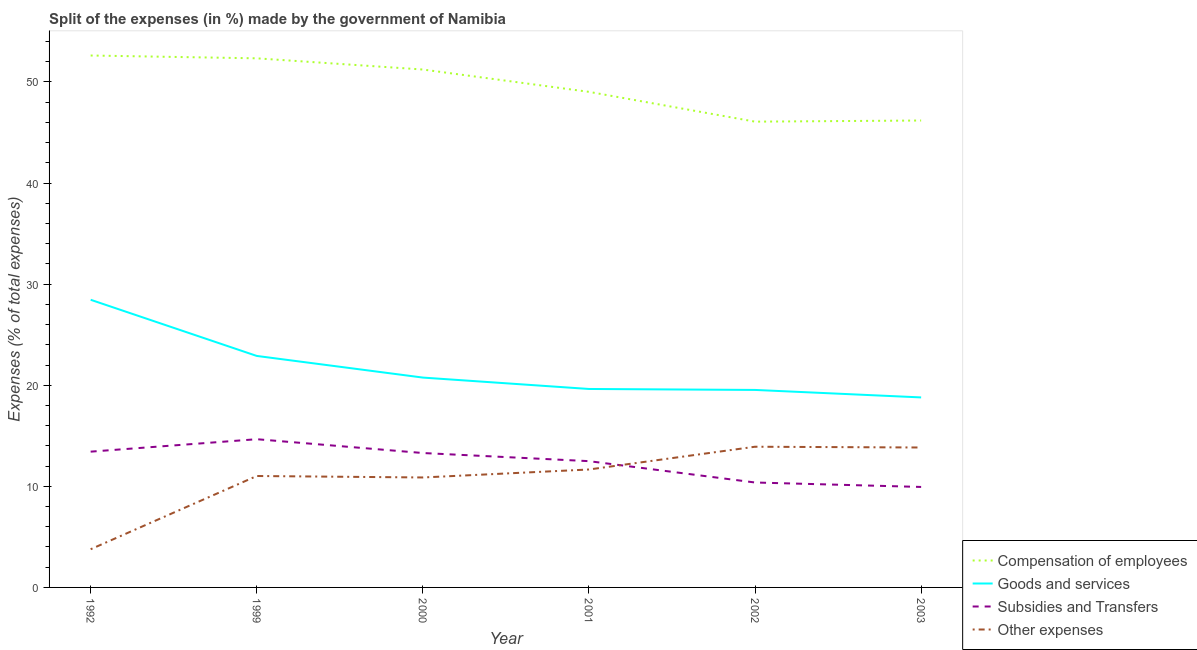Is the number of lines equal to the number of legend labels?
Your answer should be very brief. Yes. What is the percentage of amount spent on compensation of employees in 1992?
Your answer should be compact. 52.62. Across all years, what is the maximum percentage of amount spent on goods and services?
Offer a very short reply. 28.46. Across all years, what is the minimum percentage of amount spent on goods and services?
Keep it short and to the point. 18.8. What is the total percentage of amount spent on other expenses in the graph?
Your answer should be very brief. 65.1. What is the difference between the percentage of amount spent on compensation of employees in 2001 and that in 2002?
Your response must be concise. 2.95. What is the difference between the percentage of amount spent on compensation of employees in 2002 and the percentage of amount spent on goods and services in 2003?
Offer a very short reply. 27.28. What is the average percentage of amount spent on subsidies per year?
Offer a very short reply. 12.37. In the year 1992, what is the difference between the percentage of amount spent on other expenses and percentage of amount spent on goods and services?
Ensure brevity in your answer.  -24.68. In how many years, is the percentage of amount spent on goods and services greater than 38 %?
Make the answer very short. 0. What is the ratio of the percentage of amount spent on compensation of employees in 1992 to that in 2000?
Make the answer very short. 1.03. Is the difference between the percentage of amount spent on subsidies in 1999 and 2001 greater than the difference between the percentage of amount spent on other expenses in 1999 and 2001?
Your answer should be compact. Yes. What is the difference between the highest and the second highest percentage of amount spent on other expenses?
Provide a succinct answer. 0.08. What is the difference between the highest and the lowest percentage of amount spent on compensation of employees?
Give a very brief answer. 6.54. In how many years, is the percentage of amount spent on subsidies greater than the average percentage of amount spent on subsidies taken over all years?
Keep it short and to the point. 4. Does the percentage of amount spent on goods and services monotonically increase over the years?
Your answer should be compact. No. Is the percentage of amount spent on other expenses strictly greater than the percentage of amount spent on compensation of employees over the years?
Provide a succinct answer. No. What is the difference between two consecutive major ticks on the Y-axis?
Offer a terse response. 10. Does the graph contain grids?
Give a very brief answer. No. How many legend labels are there?
Your answer should be compact. 4. How are the legend labels stacked?
Provide a succinct answer. Vertical. What is the title of the graph?
Provide a short and direct response. Split of the expenses (in %) made by the government of Namibia. Does "Iceland" appear as one of the legend labels in the graph?
Provide a short and direct response. No. What is the label or title of the Y-axis?
Make the answer very short. Expenses (% of total expenses). What is the Expenses (% of total expenses) of Compensation of employees in 1992?
Offer a very short reply. 52.62. What is the Expenses (% of total expenses) of Goods and services in 1992?
Your answer should be compact. 28.46. What is the Expenses (% of total expenses) of Subsidies and Transfers in 1992?
Your response must be concise. 13.43. What is the Expenses (% of total expenses) of Other expenses in 1992?
Your answer should be very brief. 3.78. What is the Expenses (% of total expenses) of Compensation of employees in 1999?
Your answer should be compact. 52.34. What is the Expenses (% of total expenses) of Goods and services in 1999?
Offer a terse response. 22.9. What is the Expenses (% of total expenses) in Subsidies and Transfers in 1999?
Make the answer very short. 14.66. What is the Expenses (% of total expenses) in Other expenses in 1999?
Make the answer very short. 11.02. What is the Expenses (% of total expenses) in Compensation of employees in 2000?
Ensure brevity in your answer.  51.23. What is the Expenses (% of total expenses) of Goods and services in 2000?
Your response must be concise. 20.76. What is the Expenses (% of total expenses) in Subsidies and Transfers in 2000?
Keep it short and to the point. 13.3. What is the Expenses (% of total expenses) of Other expenses in 2000?
Your response must be concise. 10.88. What is the Expenses (% of total expenses) in Compensation of employees in 2001?
Make the answer very short. 49.02. What is the Expenses (% of total expenses) in Goods and services in 2001?
Provide a short and direct response. 19.63. What is the Expenses (% of total expenses) of Subsidies and Transfers in 2001?
Provide a short and direct response. 12.49. What is the Expenses (% of total expenses) of Other expenses in 2001?
Offer a terse response. 11.67. What is the Expenses (% of total expenses) of Compensation of employees in 2002?
Ensure brevity in your answer.  46.08. What is the Expenses (% of total expenses) of Goods and services in 2002?
Offer a very short reply. 19.54. What is the Expenses (% of total expenses) of Subsidies and Transfers in 2002?
Keep it short and to the point. 10.38. What is the Expenses (% of total expenses) of Other expenses in 2002?
Your answer should be very brief. 13.92. What is the Expenses (% of total expenses) of Compensation of employees in 2003?
Your response must be concise. 46.19. What is the Expenses (% of total expenses) of Goods and services in 2003?
Offer a very short reply. 18.8. What is the Expenses (% of total expenses) of Subsidies and Transfers in 2003?
Your answer should be compact. 9.94. What is the Expenses (% of total expenses) in Other expenses in 2003?
Offer a very short reply. 13.84. Across all years, what is the maximum Expenses (% of total expenses) in Compensation of employees?
Give a very brief answer. 52.62. Across all years, what is the maximum Expenses (% of total expenses) in Goods and services?
Give a very brief answer. 28.46. Across all years, what is the maximum Expenses (% of total expenses) of Subsidies and Transfers?
Your answer should be compact. 14.66. Across all years, what is the maximum Expenses (% of total expenses) in Other expenses?
Offer a terse response. 13.92. Across all years, what is the minimum Expenses (% of total expenses) in Compensation of employees?
Ensure brevity in your answer.  46.08. Across all years, what is the minimum Expenses (% of total expenses) of Goods and services?
Keep it short and to the point. 18.8. Across all years, what is the minimum Expenses (% of total expenses) of Subsidies and Transfers?
Provide a short and direct response. 9.94. Across all years, what is the minimum Expenses (% of total expenses) of Other expenses?
Make the answer very short. 3.78. What is the total Expenses (% of total expenses) in Compensation of employees in the graph?
Offer a very short reply. 297.48. What is the total Expenses (% of total expenses) in Goods and services in the graph?
Your answer should be very brief. 130.08. What is the total Expenses (% of total expenses) in Subsidies and Transfers in the graph?
Offer a terse response. 74.2. What is the total Expenses (% of total expenses) in Other expenses in the graph?
Provide a succinct answer. 65.1. What is the difference between the Expenses (% of total expenses) in Compensation of employees in 1992 and that in 1999?
Give a very brief answer. 0.28. What is the difference between the Expenses (% of total expenses) of Goods and services in 1992 and that in 1999?
Your answer should be very brief. 5.56. What is the difference between the Expenses (% of total expenses) in Subsidies and Transfers in 1992 and that in 1999?
Make the answer very short. -1.23. What is the difference between the Expenses (% of total expenses) of Other expenses in 1992 and that in 1999?
Your answer should be compact. -7.24. What is the difference between the Expenses (% of total expenses) of Compensation of employees in 1992 and that in 2000?
Your answer should be compact. 1.39. What is the difference between the Expenses (% of total expenses) in Goods and services in 1992 and that in 2000?
Offer a very short reply. 7.7. What is the difference between the Expenses (% of total expenses) of Subsidies and Transfers in 1992 and that in 2000?
Offer a very short reply. 0.14. What is the difference between the Expenses (% of total expenses) of Other expenses in 1992 and that in 2000?
Your answer should be compact. -7.1. What is the difference between the Expenses (% of total expenses) of Compensation of employees in 1992 and that in 2001?
Your response must be concise. 3.59. What is the difference between the Expenses (% of total expenses) of Goods and services in 1992 and that in 2001?
Your answer should be very brief. 8.82. What is the difference between the Expenses (% of total expenses) in Subsidies and Transfers in 1992 and that in 2001?
Offer a terse response. 0.94. What is the difference between the Expenses (% of total expenses) in Other expenses in 1992 and that in 2001?
Provide a short and direct response. -7.89. What is the difference between the Expenses (% of total expenses) in Compensation of employees in 1992 and that in 2002?
Keep it short and to the point. 6.54. What is the difference between the Expenses (% of total expenses) in Goods and services in 1992 and that in 2002?
Offer a terse response. 8.92. What is the difference between the Expenses (% of total expenses) of Subsidies and Transfers in 1992 and that in 2002?
Offer a very short reply. 3.05. What is the difference between the Expenses (% of total expenses) of Other expenses in 1992 and that in 2002?
Your answer should be very brief. -10.14. What is the difference between the Expenses (% of total expenses) in Compensation of employees in 1992 and that in 2003?
Your response must be concise. 6.43. What is the difference between the Expenses (% of total expenses) of Goods and services in 1992 and that in 2003?
Offer a very short reply. 9.66. What is the difference between the Expenses (% of total expenses) in Subsidies and Transfers in 1992 and that in 2003?
Your answer should be very brief. 3.49. What is the difference between the Expenses (% of total expenses) in Other expenses in 1992 and that in 2003?
Your answer should be very brief. -10.06. What is the difference between the Expenses (% of total expenses) of Compensation of employees in 1999 and that in 2000?
Ensure brevity in your answer.  1.11. What is the difference between the Expenses (% of total expenses) of Goods and services in 1999 and that in 2000?
Your answer should be very brief. 2.14. What is the difference between the Expenses (% of total expenses) of Subsidies and Transfers in 1999 and that in 2000?
Ensure brevity in your answer.  1.37. What is the difference between the Expenses (% of total expenses) of Other expenses in 1999 and that in 2000?
Your answer should be compact. 0.15. What is the difference between the Expenses (% of total expenses) in Compensation of employees in 1999 and that in 2001?
Provide a succinct answer. 3.32. What is the difference between the Expenses (% of total expenses) of Goods and services in 1999 and that in 2001?
Offer a terse response. 3.27. What is the difference between the Expenses (% of total expenses) of Subsidies and Transfers in 1999 and that in 2001?
Ensure brevity in your answer.  2.17. What is the difference between the Expenses (% of total expenses) in Other expenses in 1999 and that in 2001?
Keep it short and to the point. -0.64. What is the difference between the Expenses (% of total expenses) of Compensation of employees in 1999 and that in 2002?
Your answer should be very brief. 6.26. What is the difference between the Expenses (% of total expenses) in Goods and services in 1999 and that in 2002?
Offer a very short reply. 3.36. What is the difference between the Expenses (% of total expenses) in Subsidies and Transfers in 1999 and that in 2002?
Offer a terse response. 4.28. What is the difference between the Expenses (% of total expenses) in Other expenses in 1999 and that in 2002?
Your answer should be compact. -2.9. What is the difference between the Expenses (% of total expenses) in Compensation of employees in 1999 and that in 2003?
Ensure brevity in your answer.  6.15. What is the difference between the Expenses (% of total expenses) in Goods and services in 1999 and that in 2003?
Your answer should be compact. 4.11. What is the difference between the Expenses (% of total expenses) of Subsidies and Transfers in 1999 and that in 2003?
Your response must be concise. 4.72. What is the difference between the Expenses (% of total expenses) of Other expenses in 1999 and that in 2003?
Give a very brief answer. -2.82. What is the difference between the Expenses (% of total expenses) of Compensation of employees in 2000 and that in 2001?
Ensure brevity in your answer.  2.21. What is the difference between the Expenses (% of total expenses) of Goods and services in 2000 and that in 2001?
Offer a very short reply. 1.13. What is the difference between the Expenses (% of total expenses) of Subsidies and Transfers in 2000 and that in 2001?
Ensure brevity in your answer.  0.8. What is the difference between the Expenses (% of total expenses) in Other expenses in 2000 and that in 2001?
Offer a terse response. -0.79. What is the difference between the Expenses (% of total expenses) of Compensation of employees in 2000 and that in 2002?
Offer a very short reply. 5.16. What is the difference between the Expenses (% of total expenses) of Goods and services in 2000 and that in 2002?
Your answer should be very brief. 1.22. What is the difference between the Expenses (% of total expenses) in Subsidies and Transfers in 2000 and that in 2002?
Offer a terse response. 2.92. What is the difference between the Expenses (% of total expenses) of Other expenses in 2000 and that in 2002?
Ensure brevity in your answer.  -3.04. What is the difference between the Expenses (% of total expenses) in Compensation of employees in 2000 and that in 2003?
Give a very brief answer. 5.04. What is the difference between the Expenses (% of total expenses) in Goods and services in 2000 and that in 2003?
Provide a succinct answer. 1.96. What is the difference between the Expenses (% of total expenses) in Subsidies and Transfers in 2000 and that in 2003?
Your answer should be compact. 3.36. What is the difference between the Expenses (% of total expenses) in Other expenses in 2000 and that in 2003?
Make the answer very short. -2.96. What is the difference between the Expenses (% of total expenses) of Compensation of employees in 2001 and that in 2002?
Your response must be concise. 2.95. What is the difference between the Expenses (% of total expenses) in Goods and services in 2001 and that in 2002?
Give a very brief answer. 0.1. What is the difference between the Expenses (% of total expenses) of Subsidies and Transfers in 2001 and that in 2002?
Offer a terse response. 2.11. What is the difference between the Expenses (% of total expenses) of Other expenses in 2001 and that in 2002?
Keep it short and to the point. -2.25. What is the difference between the Expenses (% of total expenses) in Compensation of employees in 2001 and that in 2003?
Your answer should be very brief. 2.84. What is the difference between the Expenses (% of total expenses) of Goods and services in 2001 and that in 2003?
Provide a succinct answer. 0.84. What is the difference between the Expenses (% of total expenses) in Subsidies and Transfers in 2001 and that in 2003?
Give a very brief answer. 2.55. What is the difference between the Expenses (% of total expenses) in Other expenses in 2001 and that in 2003?
Give a very brief answer. -2.17. What is the difference between the Expenses (% of total expenses) in Compensation of employees in 2002 and that in 2003?
Provide a succinct answer. -0.11. What is the difference between the Expenses (% of total expenses) in Goods and services in 2002 and that in 2003?
Make the answer very short. 0.74. What is the difference between the Expenses (% of total expenses) of Subsidies and Transfers in 2002 and that in 2003?
Provide a succinct answer. 0.44. What is the difference between the Expenses (% of total expenses) of Other expenses in 2002 and that in 2003?
Provide a short and direct response. 0.08. What is the difference between the Expenses (% of total expenses) in Compensation of employees in 1992 and the Expenses (% of total expenses) in Goods and services in 1999?
Keep it short and to the point. 29.72. What is the difference between the Expenses (% of total expenses) in Compensation of employees in 1992 and the Expenses (% of total expenses) in Subsidies and Transfers in 1999?
Make the answer very short. 37.96. What is the difference between the Expenses (% of total expenses) in Compensation of employees in 1992 and the Expenses (% of total expenses) in Other expenses in 1999?
Provide a short and direct response. 41.6. What is the difference between the Expenses (% of total expenses) of Goods and services in 1992 and the Expenses (% of total expenses) of Subsidies and Transfers in 1999?
Give a very brief answer. 13.79. What is the difference between the Expenses (% of total expenses) of Goods and services in 1992 and the Expenses (% of total expenses) of Other expenses in 1999?
Your answer should be compact. 17.43. What is the difference between the Expenses (% of total expenses) in Subsidies and Transfers in 1992 and the Expenses (% of total expenses) in Other expenses in 1999?
Your answer should be very brief. 2.41. What is the difference between the Expenses (% of total expenses) in Compensation of employees in 1992 and the Expenses (% of total expenses) in Goods and services in 2000?
Give a very brief answer. 31.86. What is the difference between the Expenses (% of total expenses) of Compensation of employees in 1992 and the Expenses (% of total expenses) of Subsidies and Transfers in 2000?
Provide a succinct answer. 39.32. What is the difference between the Expenses (% of total expenses) in Compensation of employees in 1992 and the Expenses (% of total expenses) in Other expenses in 2000?
Offer a very short reply. 41.74. What is the difference between the Expenses (% of total expenses) in Goods and services in 1992 and the Expenses (% of total expenses) in Subsidies and Transfers in 2000?
Make the answer very short. 15.16. What is the difference between the Expenses (% of total expenses) of Goods and services in 1992 and the Expenses (% of total expenses) of Other expenses in 2000?
Give a very brief answer. 17.58. What is the difference between the Expenses (% of total expenses) in Subsidies and Transfers in 1992 and the Expenses (% of total expenses) in Other expenses in 2000?
Provide a succinct answer. 2.55. What is the difference between the Expenses (% of total expenses) in Compensation of employees in 1992 and the Expenses (% of total expenses) in Goods and services in 2001?
Offer a terse response. 32.99. What is the difference between the Expenses (% of total expenses) of Compensation of employees in 1992 and the Expenses (% of total expenses) of Subsidies and Transfers in 2001?
Your answer should be compact. 40.13. What is the difference between the Expenses (% of total expenses) in Compensation of employees in 1992 and the Expenses (% of total expenses) in Other expenses in 2001?
Offer a terse response. 40.95. What is the difference between the Expenses (% of total expenses) of Goods and services in 1992 and the Expenses (% of total expenses) of Subsidies and Transfers in 2001?
Provide a short and direct response. 15.96. What is the difference between the Expenses (% of total expenses) of Goods and services in 1992 and the Expenses (% of total expenses) of Other expenses in 2001?
Your answer should be very brief. 16.79. What is the difference between the Expenses (% of total expenses) in Subsidies and Transfers in 1992 and the Expenses (% of total expenses) in Other expenses in 2001?
Provide a succinct answer. 1.76. What is the difference between the Expenses (% of total expenses) of Compensation of employees in 1992 and the Expenses (% of total expenses) of Goods and services in 2002?
Keep it short and to the point. 33.08. What is the difference between the Expenses (% of total expenses) of Compensation of employees in 1992 and the Expenses (% of total expenses) of Subsidies and Transfers in 2002?
Give a very brief answer. 42.24. What is the difference between the Expenses (% of total expenses) of Compensation of employees in 1992 and the Expenses (% of total expenses) of Other expenses in 2002?
Give a very brief answer. 38.7. What is the difference between the Expenses (% of total expenses) in Goods and services in 1992 and the Expenses (% of total expenses) in Subsidies and Transfers in 2002?
Provide a succinct answer. 18.08. What is the difference between the Expenses (% of total expenses) in Goods and services in 1992 and the Expenses (% of total expenses) in Other expenses in 2002?
Offer a very short reply. 14.54. What is the difference between the Expenses (% of total expenses) of Subsidies and Transfers in 1992 and the Expenses (% of total expenses) of Other expenses in 2002?
Give a very brief answer. -0.49. What is the difference between the Expenses (% of total expenses) in Compensation of employees in 1992 and the Expenses (% of total expenses) in Goods and services in 2003?
Keep it short and to the point. 33.82. What is the difference between the Expenses (% of total expenses) in Compensation of employees in 1992 and the Expenses (% of total expenses) in Subsidies and Transfers in 2003?
Offer a very short reply. 42.68. What is the difference between the Expenses (% of total expenses) of Compensation of employees in 1992 and the Expenses (% of total expenses) of Other expenses in 2003?
Offer a very short reply. 38.78. What is the difference between the Expenses (% of total expenses) of Goods and services in 1992 and the Expenses (% of total expenses) of Subsidies and Transfers in 2003?
Your answer should be compact. 18.52. What is the difference between the Expenses (% of total expenses) in Goods and services in 1992 and the Expenses (% of total expenses) in Other expenses in 2003?
Provide a succinct answer. 14.61. What is the difference between the Expenses (% of total expenses) in Subsidies and Transfers in 1992 and the Expenses (% of total expenses) in Other expenses in 2003?
Give a very brief answer. -0.41. What is the difference between the Expenses (% of total expenses) of Compensation of employees in 1999 and the Expenses (% of total expenses) of Goods and services in 2000?
Make the answer very short. 31.58. What is the difference between the Expenses (% of total expenses) in Compensation of employees in 1999 and the Expenses (% of total expenses) in Subsidies and Transfers in 2000?
Ensure brevity in your answer.  39.04. What is the difference between the Expenses (% of total expenses) of Compensation of employees in 1999 and the Expenses (% of total expenses) of Other expenses in 2000?
Offer a very short reply. 41.46. What is the difference between the Expenses (% of total expenses) of Goods and services in 1999 and the Expenses (% of total expenses) of Subsidies and Transfers in 2000?
Provide a short and direct response. 9.6. What is the difference between the Expenses (% of total expenses) of Goods and services in 1999 and the Expenses (% of total expenses) of Other expenses in 2000?
Your response must be concise. 12.02. What is the difference between the Expenses (% of total expenses) of Subsidies and Transfers in 1999 and the Expenses (% of total expenses) of Other expenses in 2000?
Make the answer very short. 3.79. What is the difference between the Expenses (% of total expenses) in Compensation of employees in 1999 and the Expenses (% of total expenses) in Goods and services in 2001?
Give a very brief answer. 32.71. What is the difference between the Expenses (% of total expenses) of Compensation of employees in 1999 and the Expenses (% of total expenses) of Subsidies and Transfers in 2001?
Give a very brief answer. 39.85. What is the difference between the Expenses (% of total expenses) of Compensation of employees in 1999 and the Expenses (% of total expenses) of Other expenses in 2001?
Your response must be concise. 40.67. What is the difference between the Expenses (% of total expenses) of Goods and services in 1999 and the Expenses (% of total expenses) of Subsidies and Transfers in 2001?
Provide a succinct answer. 10.41. What is the difference between the Expenses (% of total expenses) in Goods and services in 1999 and the Expenses (% of total expenses) in Other expenses in 2001?
Offer a terse response. 11.23. What is the difference between the Expenses (% of total expenses) in Subsidies and Transfers in 1999 and the Expenses (% of total expenses) in Other expenses in 2001?
Your answer should be compact. 3. What is the difference between the Expenses (% of total expenses) of Compensation of employees in 1999 and the Expenses (% of total expenses) of Goods and services in 2002?
Give a very brief answer. 32.8. What is the difference between the Expenses (% of total expenses) in Compensation of employees in 1999 and the Expenses (% of total expenses) in Subsidies and Transfers in 2002?
Your answer should be very brief. 41.96. What is the difference between the Expenses (% of total expenses) in Compensation of employees in 1999 and the Expenses (% of total expenses) in Other expenses in 2002?
Provide a succinct answer. 38.42. What is the difference between the Expenses (% of total expenses) of Goods and services in 1999 and the Expenses (% of total expenses) of Subsidies and Transfers in 2002?
Your response must be concise. 12.52. What is the difference between the Expenses (% of total expenses) of Goods and services in 1999 and the Expenses (% of total expenses) of Other expenses in 2002?
Keep it short and to the point. 8.98. What is the difference between the Expenses (% of total expenses) of Subsidies and Transfers in 1999 and the Expenses (% of total expenses) of Other expenses in 2002?
Your response must be concise. 0.74. What is the difference between the Expenses (% of total expenses) in Compensation of employees in 1999 and the Expenses (% of total expenses) in Goods and services in 2003?
Your answer should be very brief. 33.54. What is the difference between the Expenses (% of total expenses) of Compensation of employees in 1999 and the Expenses (% of total expenses) of Subsidies and Transfers in 2003?
Provide a succinct answer. 42.4. What is the difference between the Expenses (% of total expenses) of Compensation of employees in 1999 and the Expenses (% of total expenses) of Other expenses in 2003?
Provide a short and direct response. 38.5. What is the difference between the Expenses (% of total expenses) in Goods and services in 1999 and the Expenses (% of total expenses) in Subsidies and Transfers in 2003?
Provide a short and direct response. 12.96. What is the difference between the Expenses (% of total expenses) in Goods and services in 1999 and the Expenses (% of total expenses) in Other expenses in 2003?
Make the answer very short. 9.06. What is the difference between the Expenses (% of total expenses) in Subsidies and Transfers in 1999 and the Expenses (% of total expenses) in Other expenses in 2003?
Offer a terse response. 0.82. What is the difference between the Expenses (% of total expenses) of Compensation of employees in 2000 and the Expenses (% of total expenses) of Goods and services in 2001?
Give a very brief answer. 31.6. What is the difference between the Expenses (% of total expenses) of Compensation of employees in 2000 and the Expenses (% of total expenses) of Subsidies and Transfers in 2001?
Your answer should be compact. 38.74. What is the difference between the Expenses (% of total expenses) in Compensation of employees in 2000 and the Expenses (% of total expenses) in Other expenses in 2001?
Keep it short and to the point. 39.57. What is the difference between the Expenses (% of total expenses) in Goods and services in 2000 and the Expenses (% of total expenses) in Subsidies and Transfers in 2001?
Your response must be concise. 8.27. What is the difference between the Expenses (% of total expenses) in Goods and services in 2000 and the Expenses (% of total expenses) in Other expenses in 2001?
Provide a succinct answer. 9.09. What is the difference between the Expenses (% of total expenses) in Subsidies and Transfers in 2000 and the Expenses (% of total expenses) in Other expenses in 2001?
Make the answer very short. 1.63. What is the difference between the Expenses (% of total expenses) of Compensation of employees in 2000 and the Expenses (% of total expenses) of Goods and services in 2002?
Give a very brief answer. 31.7. What is the difference between the Expenses (% of total expenses) of Compensation of employees in 2000 and the Expenses (% of total expenses) of Subsidies and Transfers in 2002?
Provide a succinct answer. 40.85. What is the difference between the Expenses (% of total expenses) in Compensation of employees in 2000 and the Expenses (% of total expenses) in Other expenses in 2002?
Offer a terse response. 37.31. What is the difference between the Expenses (% of total expenses) in Goods and services in 2000 and the Expenses (% of total expenses) in Subsidies and Transfers in 2002?
Offer a terse response. 10.38. What is the difference between the Expenses (% of total expenses) of Goods and services in 2000 and the Expenses (% of total expenses) of Other expenses in 2002?
Your response must be concise. 6.84. What is the difference between the Expenses (% of total expenses) of Subsidies and Transfers in 2000 and the Expenses (% of total expenses) of Other expenses in 2002?
Keep it short and to the point. -0.62. What is the difference between the Expenses (% of total expenses) of Compensation of employees in 2000 and the Expenses (% of total expenses) of Goods and services in 2003?
Provide a succinct answer. 32.44. What is the difference between the Expenses (% of total expenses) of Compensation of employees in 2000 and the Expenses (% of total expenses) of Subsidies and Transfers in 2003?
Offer a terse response. 41.29. What is the difference between the Expenses (% of total expenses) of Compensation of employees in 2000 and the Expenses (% of total expenses) of Other expenses in 2003?
Ensure brevity in your answer.  37.39. What is the difference between the Expenses (% of total expenses) in Goods and services in 2000 and the Expenses (% of total expenses) in Subsidies and Transfers in 2003?
Provide a short and direct response. 10.82. What is the difference between the Expenses (% of total expenses) of Goods and services in 2000 and the Expenses (% of total expenses) of Other expenses in 2003?
Offer a terse response. 6.92. What is the difference between the Expenses (% of total expenses) of Subsidies and Transfers in 2000 and the Expenses (% of total expenses) of Other expenses in 2003?
Make the answer very short. -0.55. What is the difference between the Expenses (% of total expenses) of Compensation of employees in 2001 and the Expenses (% of total expenses) of Goods and services in 2002?
Offer a very short reply. 29.49. What is the difference between the Expenses (% of total expenses) of Compensation of employees in 2001 and the Expenses (% of total expenses) of Subsidies and Transfers in 2002?
Your answer should be compact. 38.64. What is the difference between the Expenses (% of total expenses) of Compensation of employees in 2001 and the Expenses (% of total expenses) of Other expenses in 2002?
Ensure brevity in your answer.  35.11. What is the difference between the Expenses (% of total expenses) in Goods and services in 2001 and the Expenses (% of total expenses) in Subsidies and Transfers in 2002?
Ensure brevity in your answer.  9.25. What is the difference between the Expenses (% of total expenses) of Goods and services in 2001 and the Expenses (% of total expenses) of Other expenses in 2002?
Ensure brevity in your answer.  5.71. What is the difference between the Expenses (% of total expenses) of Subsidies and Transfers in 2001 and the Expenses (% of total expenses) of Other expenses in 2002?
Offer a very short reply. -1.43. What is the difference between the Expenses (% of total expenses) in Compensation of employees in 2001 and the Expenses (% of total expenses) in Goods and services in 2003?
Provide a short and direct response. 30.23. What is the difference between the Expenses (% of total expenses) of Compensation of employees in 2001 and the Expenses (% of total expenses) of Subsidies and Transfers in 2003?
Ensure brevity in your answer.  39.08. What is the difference between the Expenses (% of total expenses) in Compensation of employees in 2001 and the Expenses (% of total expenses) in Other expenses in 2003?
Offer a very short reply. 35.18. What is the difference between the Expenses (% of total expenses) in Goods and services in 2001 and the Expenses (% of total expenses) in Subsidies and Transfers in 2003?
Make the answer very short. 9.69. What is the difference between the Expenses (% of total expenses) of Goods and services in 2001 and the Expenses (% of total expenses) of Other expenses in 2003?
Offer a terse response. 5.79. What is the difference between the Expenses (% of total expenses) of Subsidies and Transfers in 2001 and the Expenses (% of total expenses) of Other expenses in 2003?
Ensure brevity in your answer.  -1.35. What is the difference between the Expenses (% of total expenses) of Compensation of employees in 2002 and the Expenses (% of total expenses) of Goods and services in 2003?
Keep it short and to the point. 27.28. What is the difference between the Expenses (% of total expenses) in Compensation of employees in 2002 and the Expenses (% of total expenses) in Subsidies and Transfers in 2003?
Your answer should be very brief. 36.14. What is the difference between the Expenses (% of total expenses) in Compensation of employees in 2002 and the Expenses (% of total expenses) in Other expenses in 2003?
Provide a short and direct response. 32.23. What is the difference between the Expenses (% of total expenses) of Goods and services in 2002 and the Expenses (% of total expenses) of Subsidies and Transfers in 2003?
Provide a succinct answer. 9.6. What is the difference between the Expenses (% of total expenses) of Goods and services in 2002 and the Expenses (% of total expenses) of Other expenses in 2003?
Ensure brevity in your answer.  5.7. What is the difference between the Expenses (% of total expenses) of Subsidies and Transfers in 2002 and the Expenses (% of total expenses) of Other expenses in 2003?
Keep it short and to the point. -3.46. What is the average Expenses (% of total expenses) of Compensation of employees per year?
Provide a succinct answer. 49.58. What is the average Expenses (% of total expenses) in Goods and services per year?
Make the answer very short. 21.68. What is the average Expenses (% of total expenses) of Subsidies and Transfers per year?
Keep it short and to the point. 12.37. What is the average Expenses (% of total expenses) in Other expenses per year?
Your answer should be very brief. 10.85. In the year 1992, what is the difference between the Expenses (% of total expenses) of Compensation of employees and Expenses (% of total expenses) of Goods and services?
Give a very brief answer. 24.16. In the year 1992, what is the difference between the Expenses (% of total expenses) in Compensation of employees and Expenses (% of total expenses) in Subsidies and Transfers?
Your answer should be compact. 39.19. In the year 1992, what is the difference between the Expenses (% of total expenses) of Compensation of employees and Expenses (% of total expenses) of Other expenses?
Your answer should be very brief. 48.84. In the year 1992, what is the difference between the Expenses (% of total expenses) in Goods and services and Expenses (% of total expenses) in Subsidies and Transfers?
Provide a short and direct response. 15.02. In the year 1992, what is the difference between the Expenses (% of total expenses) of Goods and services and Expenses (% of total expenses) of Other expenses?
Offer a very short reply. 24.68. In the year 1992, what is the difference between the Expenses (% of total expenses) of Subsidies and Transfers and Expenses (% of total expenses) of Other expenses?
Give a very brief answer. 9.65. In the year 1999, what is the difference between the Expenses (% of total expenses) of Compensation of employees and Expenses (% of total expenses) of Goods and services?
Offer a terse response. 29.44. In the year 1999, what is the difference between the Expenses (% of total expenses) of Compensation of employees and Expenses (% of total expenses) of Subsidies and Transfers?
Offer a terse response. 37.68. In the year 1999, what is the difference between the Expenses (% of total expenses) in Compensation of employees and Expenses (% of total expenses) in Other expenses?
Your response must be concise. 41.32. In the year 1999, what is the difference between the Expenses (% of total expenses) of Goods and services and Expenses (% of total expenses) of Subsidies and Transfers?
Ensure brevity in your answer.  8.24. In the year 1999, what is the difference between the Expenses (% of total expenses) in Goods and services and Expenses (% of total expenses) in Other expenses?
Keep it short and to the point. 11.88. In the year 1999, what is the difference between the Expenses (% of total expenses) of Subsidies and Transfers and Expenses (% of total expenses) of Other expenses?
Your answer should be very brief. 3.64. In the year 2000, what is the difference between the Expenses (% of total expenses) in Compensation of employees and Expenses (% of total expenses) in Goods and services?
Offer a terse response. 30.47. In the year 2000, what is the difference between the Expenses (% of total expenses) in Compensation of employees and Expenses (% of total expenses) in Subsidies and Transfers?
Offer a terse response. 37.94. In the year 2000, what is the difference between the Expenses (% of total expenses) in Compensation of employees and Expenses (% of total expenses) in Other expenses?
Provide a short and direct response. 40.36. In the year 2000, what is the difference between the Expenses (% of total expenses) of Goods and services and Expenses (% of total expenses) of Subsidies and Transfers?
Your answer should be compact. 7.46. In the year 2000, what is the difference between the Expenses (% of total expenses) of Goods and services and Expenses (% of total expenses) of Other expenses?
Your response must be concise. 9.88. In the year 2000, what is the difference between the Expenses (% of total expenses) of Subsidies and Transfers and Expenses (% of total expenses) of Other expenses?
Your answer should be very brief. 2.42. In the year 2001, what is the difference between the Expenses (% of total expenses) in Compensation of employees and Expenses (% of total expenses) in Goods and services?
Provide a succinct answer. 29.39. In the year 2001, what is the difference between the Expenses (% of total expenses) in Compensation of employees and Expenses (% of total expenses) in Subsidies and Transfers?
Offer a very short reply. 36.53. In the year 2001, what is the difference between the Expenses (% of total expenses) in Compensation of employees and Expenses (% of total expenses) in Other expenses?
Offer a terse response. 37.36. In the year 2001, what is the difference between the Expenses (% of total expenses) in Goods and services and Expenses (% of total expenses) in Subsidies and Transfers?
Provide a succinct answer. 7.14. In the year 2001, what is the difference between the Expenses (% of total expenses) in Goods and services and Expenses (% of total expenses) in Other expenses?
Keep it short and to the point. 7.97. In the year 2001, what is the difference between the Expenses (% of total expenses) of Subsidies and Transfers and Expenses (% of total expenses) of Other expenses?
Ensure brevity in your answer.  0.82. In the year 2002, what is the difference between the Expenses (% of total expenses) in Compensation of employees and Expenses (% of total expenses) in Goods and services?
Your answer should be very brief. 26.54. In the year 2002, what is the difference between the Expenses (% of total expenses) of Compensation of employees and Expenses (% of total expenses) of Subsidies and Transfers?
Offer a very short reply. 35.7. In the year 2002, what is the difference between the Expenses (% of total expenses) of Compensation of employees and Expenses (% of total expenses) of Other expenses?
Make the answer very short. 32.16. In the year 2002, what is the difference between the Expenses (% of total expenses) of Goods and services and Expenses (% of total expenses) of Subsidies and Transfers?
Keep it short and to the point. 9.16. In the year 2002, what is the difference between the Expenses (% of total expenses) in Goods and services and Expenses (% of total expenses) in Other expenses?
Offer a very short reply. 5.62. In the year 2002, what is the difference between the Expenses (% of total expenses) of Subsidies and Transfers and Expenses (% of total expenses) of Other expenses?
Provide a short and direct response. -3.54. In the year 2003, what is the difference between the Expenses (% of total expenses) in Compensation of employees and Expenses (% of total expenses) in Goods and services?
Ensure brevity in your answer.  27.39. In the year 2003, what is the difference between the Expenses (% of total expenses) in Compensation of employees and Expenses (% of total expenses) in Subsidies and Transfers?
Give a very brief answer. 36.25. In the year 2003, what is the difference between the Expenses (% of total expenses) in Compensation of employees and Expenses (% of total expenses) in Other expenses?
Give a very brief answer. 32.35. In the year 2003, what is the difference between the Expenses (% of total expenses) in Goods and services and Expenses (% of total expenses) in Subsidies and Transfers?
Provide a succinct answer. 8.86. In the year 2003, what is the difference between the Expenses (% of total expenses) in Goods and services and Expenses (% of total expenses) in Other expenses?
Offer a terse response. 4.95. In the year 2003, what is the difference between the Expenses (% of total expenses) in Subsidies and Transfers and Expenses (% of total expenses) in Other expenses?
Your answer should be very brief. -3.9. What is the ratio of the Expenses (% of total expenses) in Goods and services in 1992 to that in 1999?
Provide a short and direct response. 1.24. What is the ratio of the Expenses (% of total expenses) of Subsidies and Transfers in 1992 to that in 1999?
Ensure brevity in your answer.  0.92. What is the ratio of the Expenses (% of total expenses) of Other expenses in 1992 to that in 1999?
Offer a terse response. 0.34. What is the ratio of the Expenses (% of total expenses) of Compensation of employees in 1992 to that in 2000?
Provide a succinct answer. 1.03. What is the ratio of the Expenses (% of total expenses) in Goods and services in 1992 to that in 2000?
Give a very brief answer. 1.37. What is the ratio of the Expenses (% of total expenses) in Subsidies and Transfers in 1992 to that in 2000?
Your answer should be compact. 1.01. What is the ratio of the Expenses (% of total expenses) of Other expenses in 1992 to that in 2000?
Give a very brief answer. 0.35. What is the ratio of the Expenses (% of total expenses) of Compensation of employees in 1992 to that in 2001?
Your answer should be compact. 1.07. What is the ratio of the Expenses (% of total expenses) of Goods and services in 1992 to that in 2001?
Make the answer very short. 1.45. What is the ratio of the Expenses (% of total expenses) of Subsidies and Transfers in 1992 to that in 2001?
Your answer should be very brief. 1.08. What is the ratio of the Expenses (% of total expenses) of Other expenses in 1992 to that in 2001?
Offer a very short reply. 0.32. What is the ratio of the Expenses (% of total expenses) in Compensation of employees in 1992 to that in 2002?
Give a very brief answer. 1.14. What is the ratio of the Expenses (% of total expenses) of Goods and services in 1992 to that in 2002?
Your response must be concise. 1.46. What is the ratio of the Expenses (% of total expenses) in Subsidies and Transfers in 1992 to that in 2002?
Provide a succinct answer. 1.29. What is the ratio of the Expenses (% of total expenses) of Other expenses in 1992 to that in 2002?
Keep it short and to the point. 0.27. What is the ratio of the Expenses (% of total expenses) in Compensation of employees in 1992 to that in 2003?
Make the answer very short. 1.14. What is the ratio of the Expenses (% of total expenses) in Goods and services in 1992 to that in 2003?
Make the answer very short. 1.51. What is the ratio of the Expenses (% of total expenses) of Subsidies and Transfers in 1992 to that in 2003?
Provide a short and direct response. 1.35. What is the ratio of the Expenses (% of total expenses) in Other expenses in 1992 to that in 2003?
Your answer should be very brief. 0.27. What is the ratio of the Expenses (% of total expenses) in Compensation of employees in 1999 to that in 2000?
Provide a succinct answer. 1.02. What is the ratio of the Expenses (% of total expenses) of Goods and services in 1999 to that in 2000?
Keep it short and to the point. 1.1. What is the ratio of the Expenses (% of total expenses) in Subsidies and Transfers in 1999 to that in 2000?
Your answer should be very brief. 1.1. What is the ratio of the Expenses (% of total expenses) of Other expenses in 1999 to that in 2000?
Your answer should be very brief. 1.01. What is the ratio of the Expenses (% of total expenses) in Compensation of employees in 1999 to that in 2001?
Provide a succinct answer. 1.07. What is the ratio of the Expenses (% of total expenses) of Goods and services in 1999 to that in 2001?
Ensure brevity in your answer.  1.17. What is the ratio of the Expenses (% of total expenses) in Subsidies and Transfers in 1999 to that in 2001?
Your answer should be very brief. 1.17. What is the ratio of the Expenses (% of total expenses) in Other expenses in 1999 to that in 2001?
Offer a very short reply. 0.94. What is the ratio of the Expenses (% of total expenses) of Compensation of employees in 1999 to that in 2002?
Give a very brief answer. 1.14. What is the ratio of the Expenses (% of total expenses) in Goods and services in 1999 to that in 2002?
Your response must be concise. 1.17. What is the ratio of the Expenses (% of total expenses) in Subsidies and Transfers in 1999 to that in 2002?
Your answer should be compact. 1.41. What is the ratio of the Expenses (% of total expenses) in Other expenses in 1999 to that in 2002?
Offer a terse response. 0.79. What is the ratio of the Expenses (% of total expenses) of Compensation of employees in 1999 to that in 2003?
Offer a terse response. 1.13. What is the ratio of the Expenses (% of total expenses) in Goods and services in 1999 to that in 2003?
Offer a very short reply. 1.22. What is the ratio of the Expenses (% of total expenses) in Subsidies and Transfers in 1999 to that in 2003?
Your response must be concise. 1.48. What is the ratio of the Expenses (% of total expenses) of Other expenses in 1999 to that in 2003?
Ensure brevity in your answer.  0.8. What is the ratio of the Expenses (% of total expenses) of Compensation of employees in 2000 to that in 2001?
Provide a succinct answer. 1.04. What is the ratio of the Expenses (% of total expenses) of Goods and services in 2000 to that in 2001?
Your answer should be compact. 1.06. What is the ratio of the Expenses (% of total expenses) of Subsidies and Transfers in 2000 to that in 2001?
Give a very brief answer. 1.06. What is the ratio of the Expenses (% of total expenses) of Other expenses in 2000 to that in 2001?
Make the answer very short. 0.93. What is the ratio of the Expenses (% of total expenses) in Compensation of employees in 2000 to that in 2002?
Offer a terse response. 1.11. What is the ratio of the Expenses (% of total expenses) in Goods and services in 2000 to that in 2002?
Provide a succinct answer. 1.06. What is the ratio of the Expenses (% of total expenses) of Subsidies and Transfers in 2000 to that in 2002?
Your response must be concise. 1.28. What is the ratio of the Expenses (% of total expenses) in Other expenses in 2000 to that in 2002?
Offer a terse response. 0.78. What is the ratio of the Expenses (% of total expenses) of Compensation of employees in 2000 to that in 2003?
Your answer should be compact. 1.11. What is the ratio of the Expenses (% of total expenses) in Goods and services in 2000 to that in 2003?
Ensure brevity in your answer.  1.1. What is the ratio of the Expenses (% of total expenses) of Subsidies and Transfers in 2000 to that in 2003?
Your response must be concise. 1.34. What is the ratio of the Expenses (% of total expenses) of Other expenses in 2000 to that in 2003?
Your answer should be very brief. 0.79. What is the ratio of the Expenses (% of total expenses) in Compensation of employees in 2001 to that in 2002?
Your answer should be very brief. 1.06. What is the ratio of the Expenses (% of total expenses) of Goods and services in 2001 to that in 2002?
Provide a succinct answer. 1. What is the ratio of the Expenses (% of total expenses) in Subsidies and Transfers in 2001 to that in 2002?
Your response must be concise. 1.2. What is the ratio of the Expenses (% of total expenses) in Other expenses in 2001 to that in 2002?
Make the answer very short. 0.84. What is the ratio of the Expenses (% of total expenses) in Compensation of employees in 2001 to that in 2003?
Offer a very short reply. 1.06. What is the ratio of the Expenses (% of total expenses) in Goods and services in 2001 to that in 2003?
Provide a succinct answer. 1.04. What is the ratio of the Expenses (% of total expenses) of Subsidies and Transfers in 2001 to that in 2003?
Provide a succinct answer. 1.26. What is the ratio of the Expenses (% of total expenses) in Other expenses in 2001 to that in 2003?
Offer a very short reply. 0.84. What is the ratio of the Expenses (% of total expenses) of Goods and services in 2002 to that in 2003?
Provide a short and direct response. 1.04. What is the ratio of the Expenses (% of total expenses) of Subsidies and Transfers in 2002 to that in 2003?
Provide a succinct answer. 1.04. What is the difference between the highest and the second highest Expenses (% of total expenses) of Compensation of employees?
Your answer should be very brief. 0.28. What is the difference between the highest and the second highest Expenses (% of total expenses) of Goods and services?
Your answer should be compact. 5.56. What is the difference between the highest and the second highest Expenses (% of total expenses) of Subsidies and Transfers?
Your answer should be very brief. 1.23. What is the difference between the highest and the second highest Expenses (% of total expenses) of Other expenses?
Give a very brief answer. 0.08. What is the difference between the highest and the lowest Expenses (% of total expenses) of Compensation of employees?
Make the answer very short. 6.54. What is the difference between the highest and the lowest Expenses (% of total expenses) in Goods and services?
Offer a very short reply. 9.66. What is the difference between the highest and the lowest Expenses (% of total expenses) in Subsidies and Transfers?
Give a very brief answer. 4.72. What is the difference between the highest and the lowest Expenses (% of total expenses) of Other expenses?
Provide a short and direct response. 10.14. 